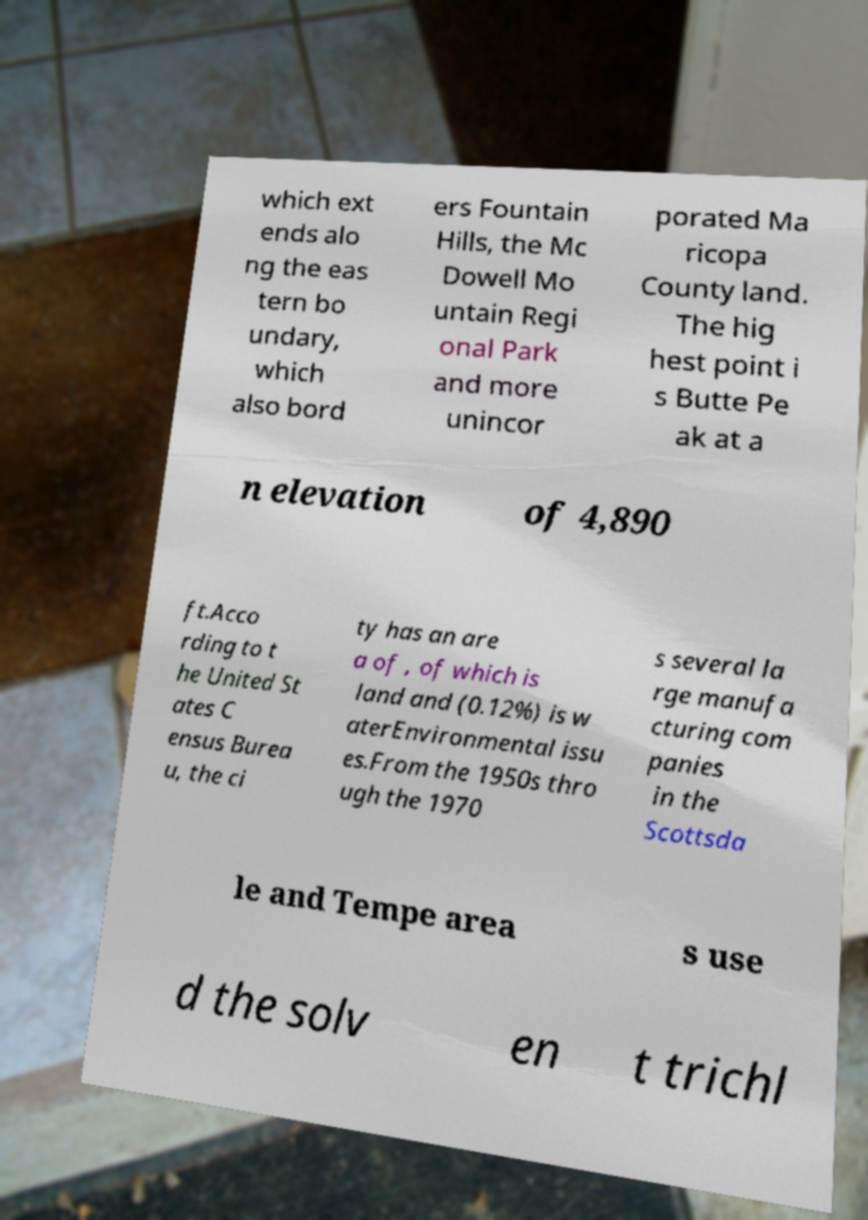For documentation purposes, I need the text within this image transcribed. Could you provide that? which ext ends alo ng the eas tern bo undary, which also bord ers Fountain Hills, the Mc Dowell Mo untain Regi onal Park and more unincor porated Ma ricopa County land. The hig hest point i s Butte Pe ak at a n elevation of 4,890 ft.Acco rding to t he United St ates C ensus Burea u, the ci ty has an are a of , of which is land and (0.12%) is w aterEnvironmental issu es.From the 1950s thro ugh the 1970 s several la rge manufa cturing com panies in the Scottsda le and Tempe area s use d the solv en t trichl 